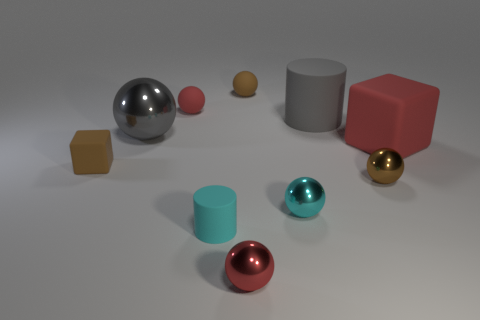There is a tiny thing behind the small red rubber sphere; does it have the same shape as the gray shiny thing?
Your answer should be compact. Yes. Is the red shiny thing the same shape as the small cyan metal thing?
Your response must be concise. Yes. Are there any small red objects that have the same shape as the small brown shiny thing?
Offer a very short reply. Yes. There is a big thing that is left of the brown matte thing to the right of the big gray shiny thing; what shape is it?
Make the answer very short. Sphere. There is a small ball on the right side of the gray matte thing; what color is it?
Provide a succinct answer. Brown. There is another block that is made of the same material as the tiny block; what size is it?
Make the answer very short. Large. What is the size of the gray shiny thing that is the same shape as the cyan metallic object?
Make the answer very short. Large. Is there a brown cylinder?
Give a very brief answer. No. How many objects are tiny balls that are in front of the big red rubber cube or small cyan spheres?
Keep it short and to the point. 3. What is the material of the cyan sphere that is the same size as the red metallic object?
Ensure brevity in your answer.  Metal. 